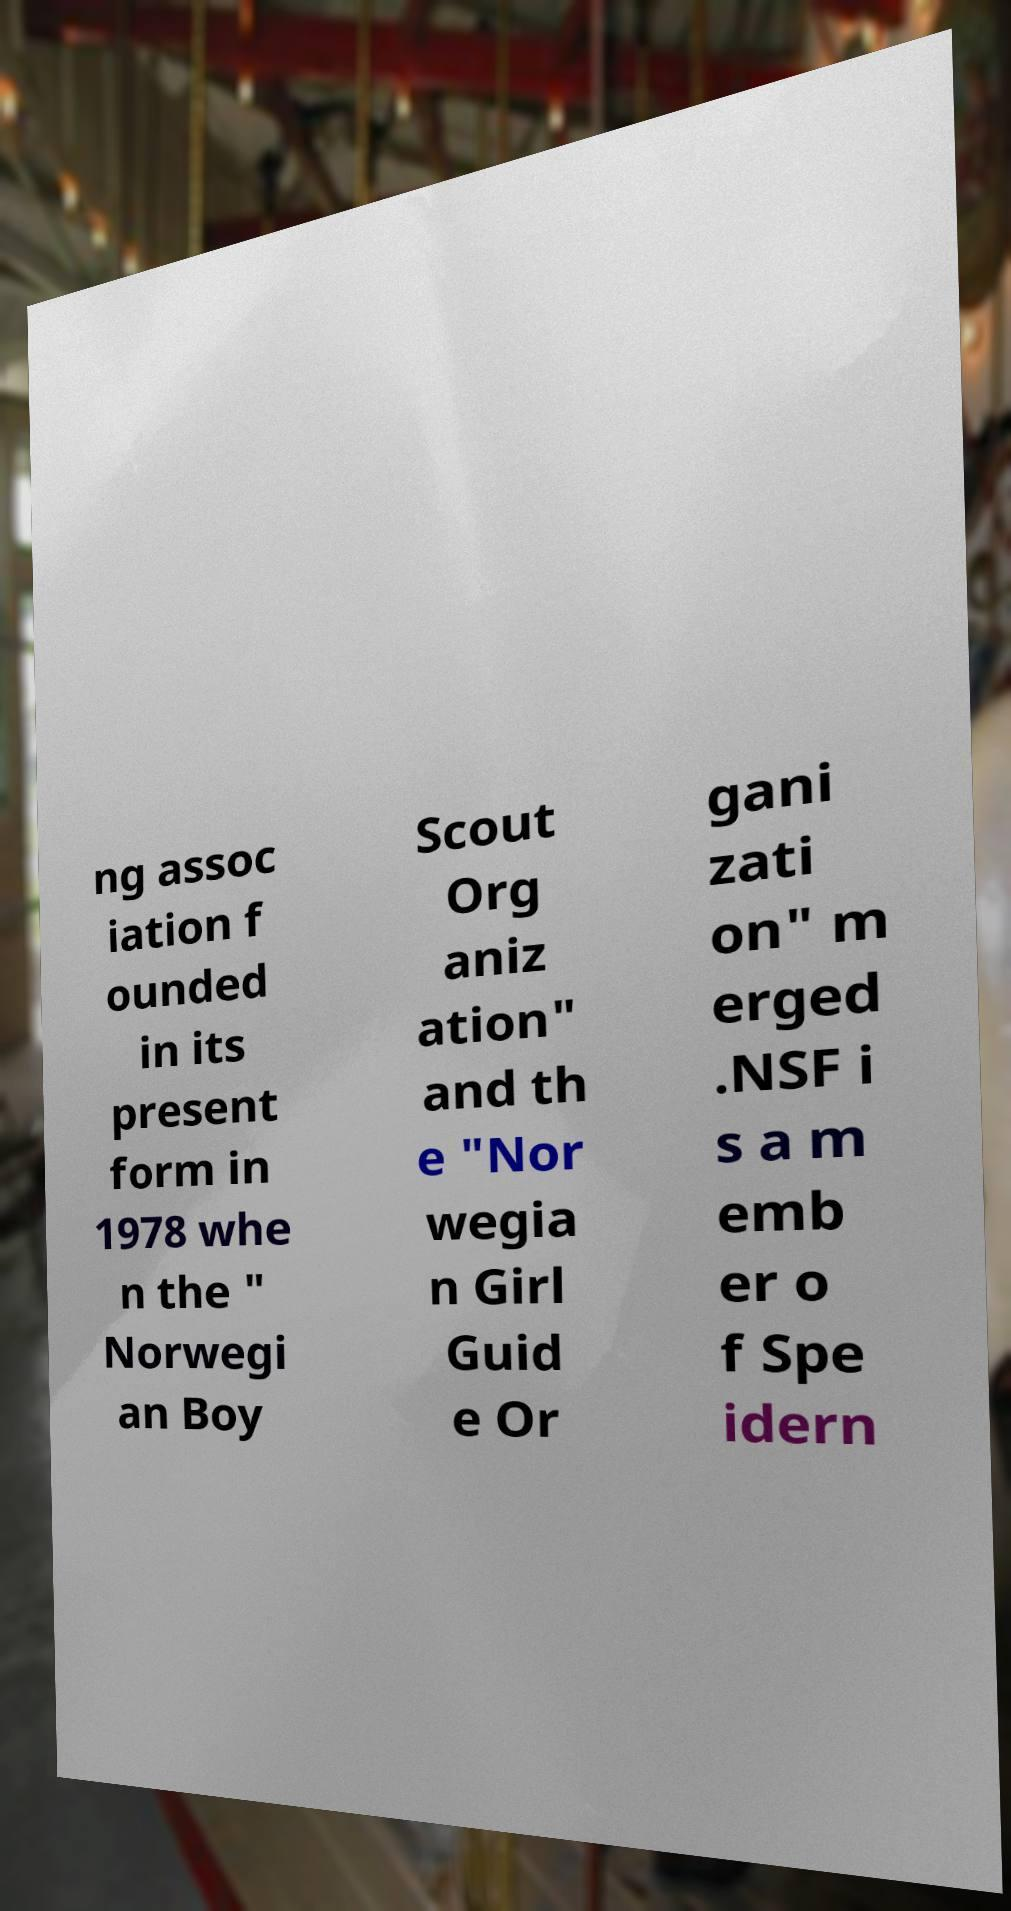Could you extract and type out the text from this image? ng assoc iation f ounded in its present form in 1978 whe n the " Norwegi an Boy Scout Org aniz ation" and th e "Nor wegia n Girl Guid e Or gani zati on" m erged .NSF i s a m emb er o f Spe idern 